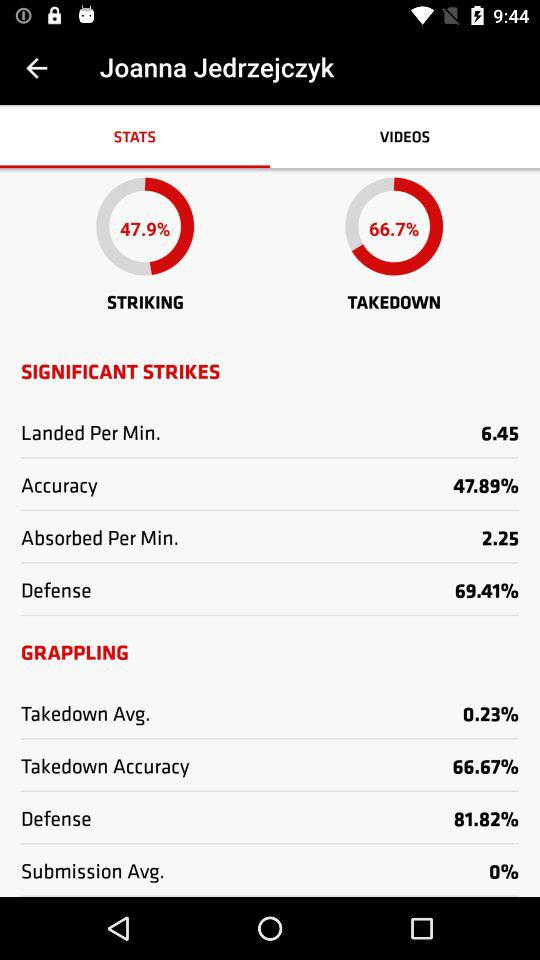How much is the striking? The striking is 47.9%. 